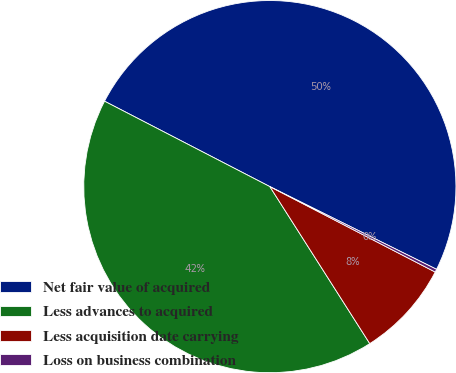Convert chart. <chart><loc_0><loc_0><loc_500><loc_500><pie_chart><fcel>Net fair value of acquired<fcel>Less advances to acquired<fcel>Less acquisition date carrying<fcel>Loss on business combination<nl><fcel>49.74%<fcel>41.61%<fcel>8.39%<fcel>0.26%<nl></chart> 